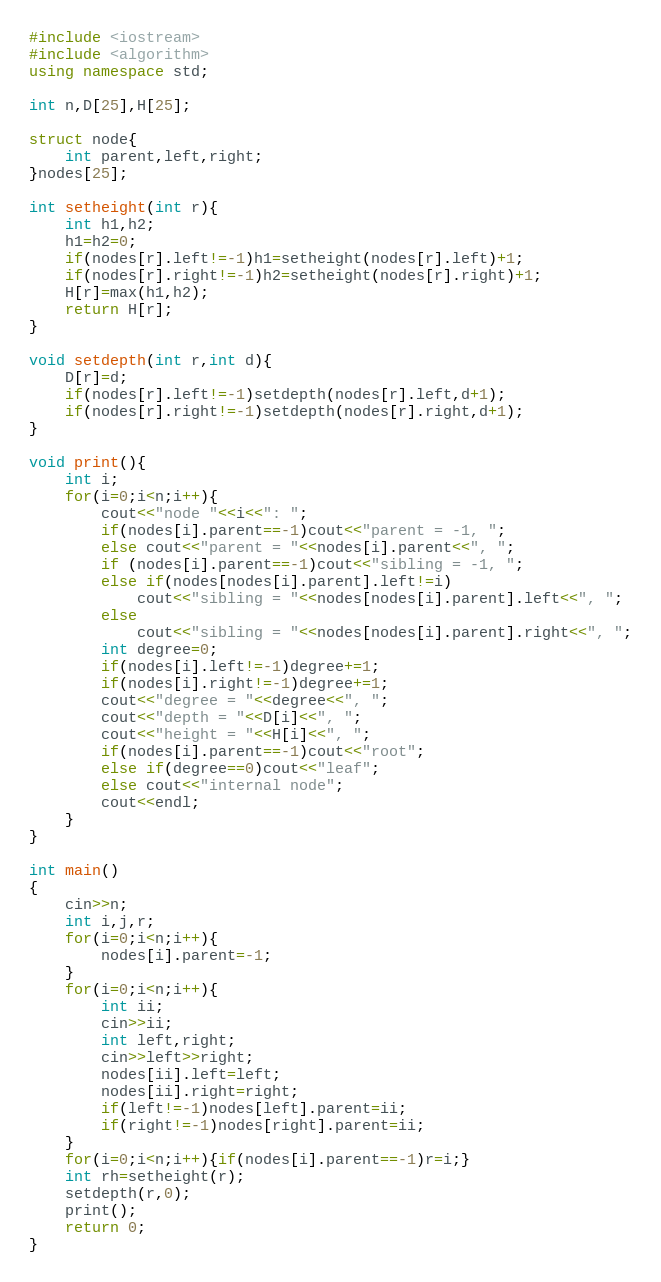<code> <loc_0><loc_0><loc_500><loc_500><_C++_>#include <iostream>
#include <algorithm>
using namespace std;

int n,D[25],H[25];

struct node{
    int parent,left,right;
}nodes[25];

int setheight(int r){
    int h1,h2;
    h1=h2=0;
    if(nodes[r].left!=-1)h1=setheight(nodes[r].left)+1;
    if(nodes[r].right!=-1)h2=setheight(nodes[r].right)+1;
    H[r]=max(h1,h2);
    return H[r];
}

void setdepth(int r,int d){
    D[r]=d;
    if(nodes[r].left!=-1)setdepth(nodes[r].left,d+1);
    if(nodes[r].right!=-1)setdepth(nodes[r].right,d+1);
}

void print(){
    int i;
    for(i=0;i<n;i++){
        cout<<"node "<<i<<": ";
        if(nodes[i].parent==-1)cout<<"parent = -1, ";
        else cout<<"parent = "<<nodes[i].parent<<", ";
        if (nodes[i].parent==-1)cout<<"sibling = -1, ";
        else if(nodes[nodes[i].parent].left!=i)
            cout<<"sibling = "<<nodes[nodes[i].parent].left<<", ";
        else
            cout<<"sibling = "<<nodes[nodes[i].parent].right<<", ";
        int degree=0;
        if(nodes[i].left!=-1)degree+=1;
        if(nodes[i].right!=-1)degree+=1;
        cout<<"degree = "<<degree<<", ";
        cout<<"depth = "<<D[i]<<", ";
        cout<<"height = "<<H[i]<<", ";
        if(nodes[i].parent==-1)cout<<"root";
        else if(degree==0)cout<<"leaf";
        else cout<<"internal node";
        cout<<endl;
    }
}

int main()
{
    cin>>n;
    int i,j,r;
    for(i=0;i<n;i++){
        nodes[i].parent=-1;
    }
    for(i=0;i<n;i++){
        int ii;
        cin>>ii;
        int left,right;
        cin>>left>>right;
        nodes[ii].left=left;
        nodes[ii].right=right;
        if(left!=-1)nodes[left].parent=ii;
        if(right!=-1)nodes[right].parent=ii;
    }
    for(i=0;i<n;i++){if(nodes[i].parent==-1)r=i;}
    int rh=setheight(r);
    setdepth(r,0);
    print();
    return 0;
}</code> 